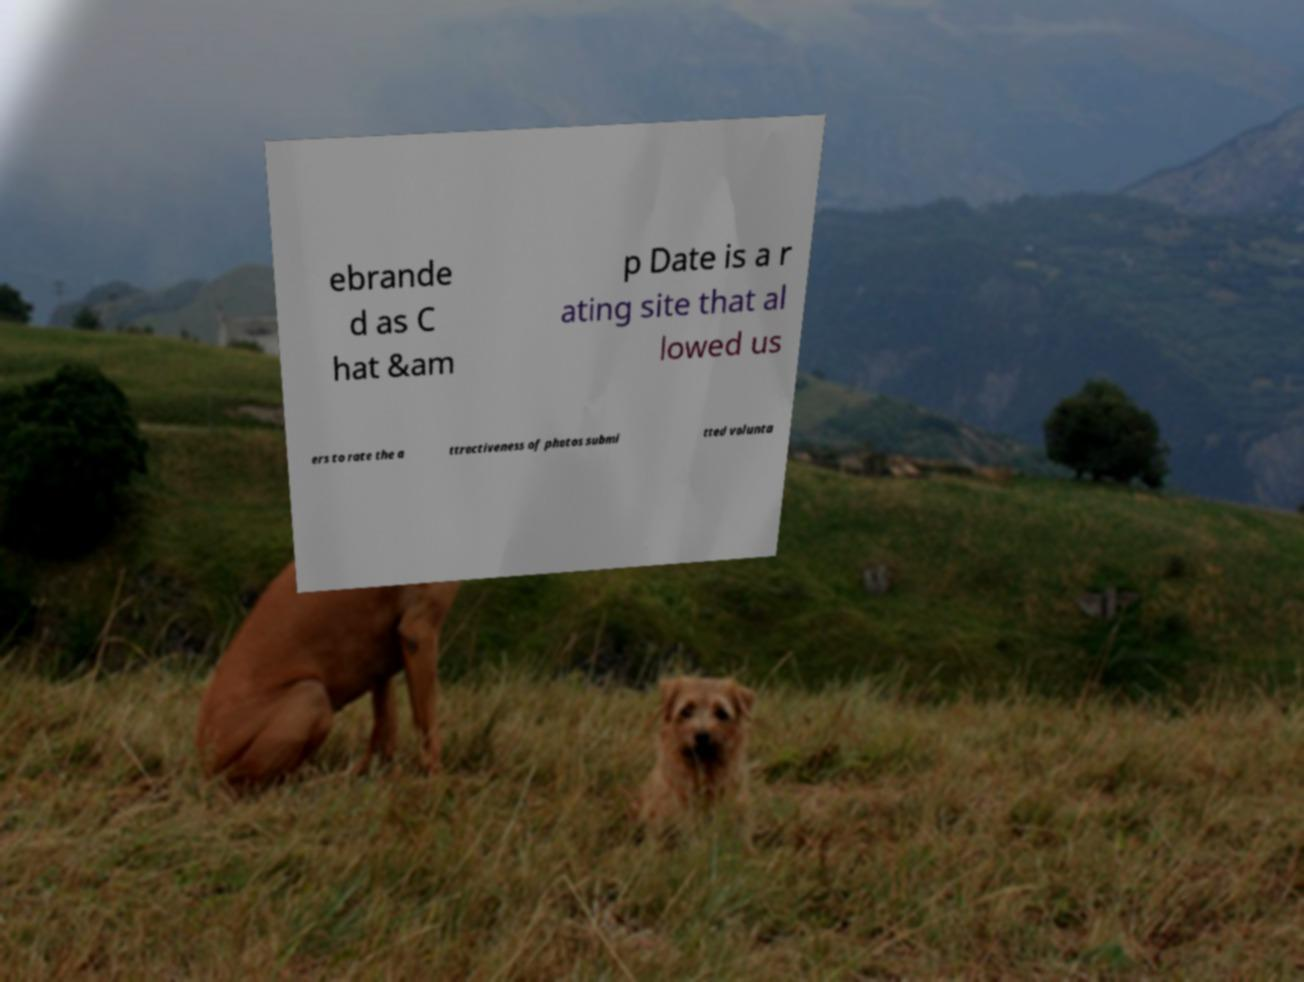Could you assist in decoding the text presented in this image and type it out clearly? ebrande d as C hat &am p Date is a r ating site that al lowed us ers to rate the a ttractiveness of photos submi tted volunta 